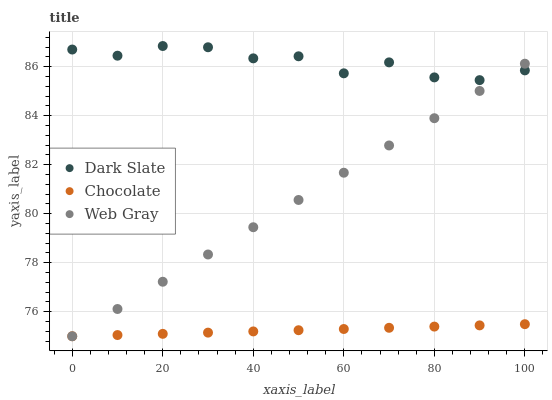Does Chocolate have the minimum area under the curve?
Answer yes or no. Yes. Does Dark Slate have the maximum area under the curve?
Answer yes or no. Yes. Does Web Gray have the minimum area under the curve?
Answer yes or no. No. Does Web Gray have the maximum area under the curve?
Answer yes or no. No. Is Chocolate the smoothest?
Answer yes or no. Yes. Is Dark Slate the roughest?
Answer yes or no. Yes. Is Web Gray the smoothest?
Answer yes or no. No. Is Web Gray the roughest?
Answer yes or no. No. Does Web Gray have the lowest value?
Answer yes or no. Yes. Does Dark Slate have the highest value?
Answer yes or no. Yes. Does Web Gray have the highest value?
Answer yes or no. No. Is Chocolate less than Dark Slate?
Answer yes or no. Yes. Is Dark Slate greater than Chocolate?
Answer yes or no. Yes. Does Web Gray intersect Chocolate?
Answer yes or no. Yes. Is Web Gray less than Chocolate?
Answer yes or no. No. Is Web Gray greater than Chocolate?
Answer yes or no. No. Does Chocolate intersect Dark Slate?
Answer yes or no. No. 